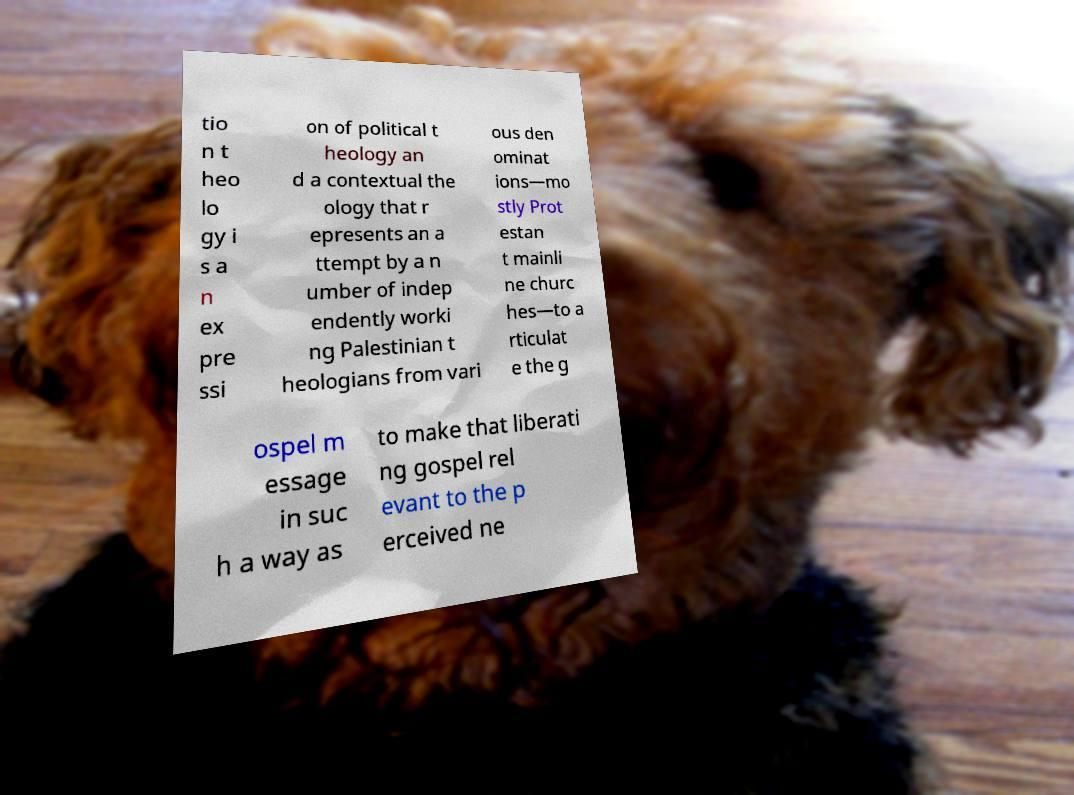What messages or text are displayed in this image? I need them in a readable, typed format. tio n t heo lo gy i s a n ex pre ssi on of political t heology an d a contextual the ology that r epresents an a ttempt by a n umber of indep endently worki ng Palestinian t heologians from vari ous den ominat ions—mo stly Prot estan t mainli ne churc hes—to a rticulat e the g ospel m essage in suc h a way as to make that liberati ng gospel rel evant to the p erceived ne 